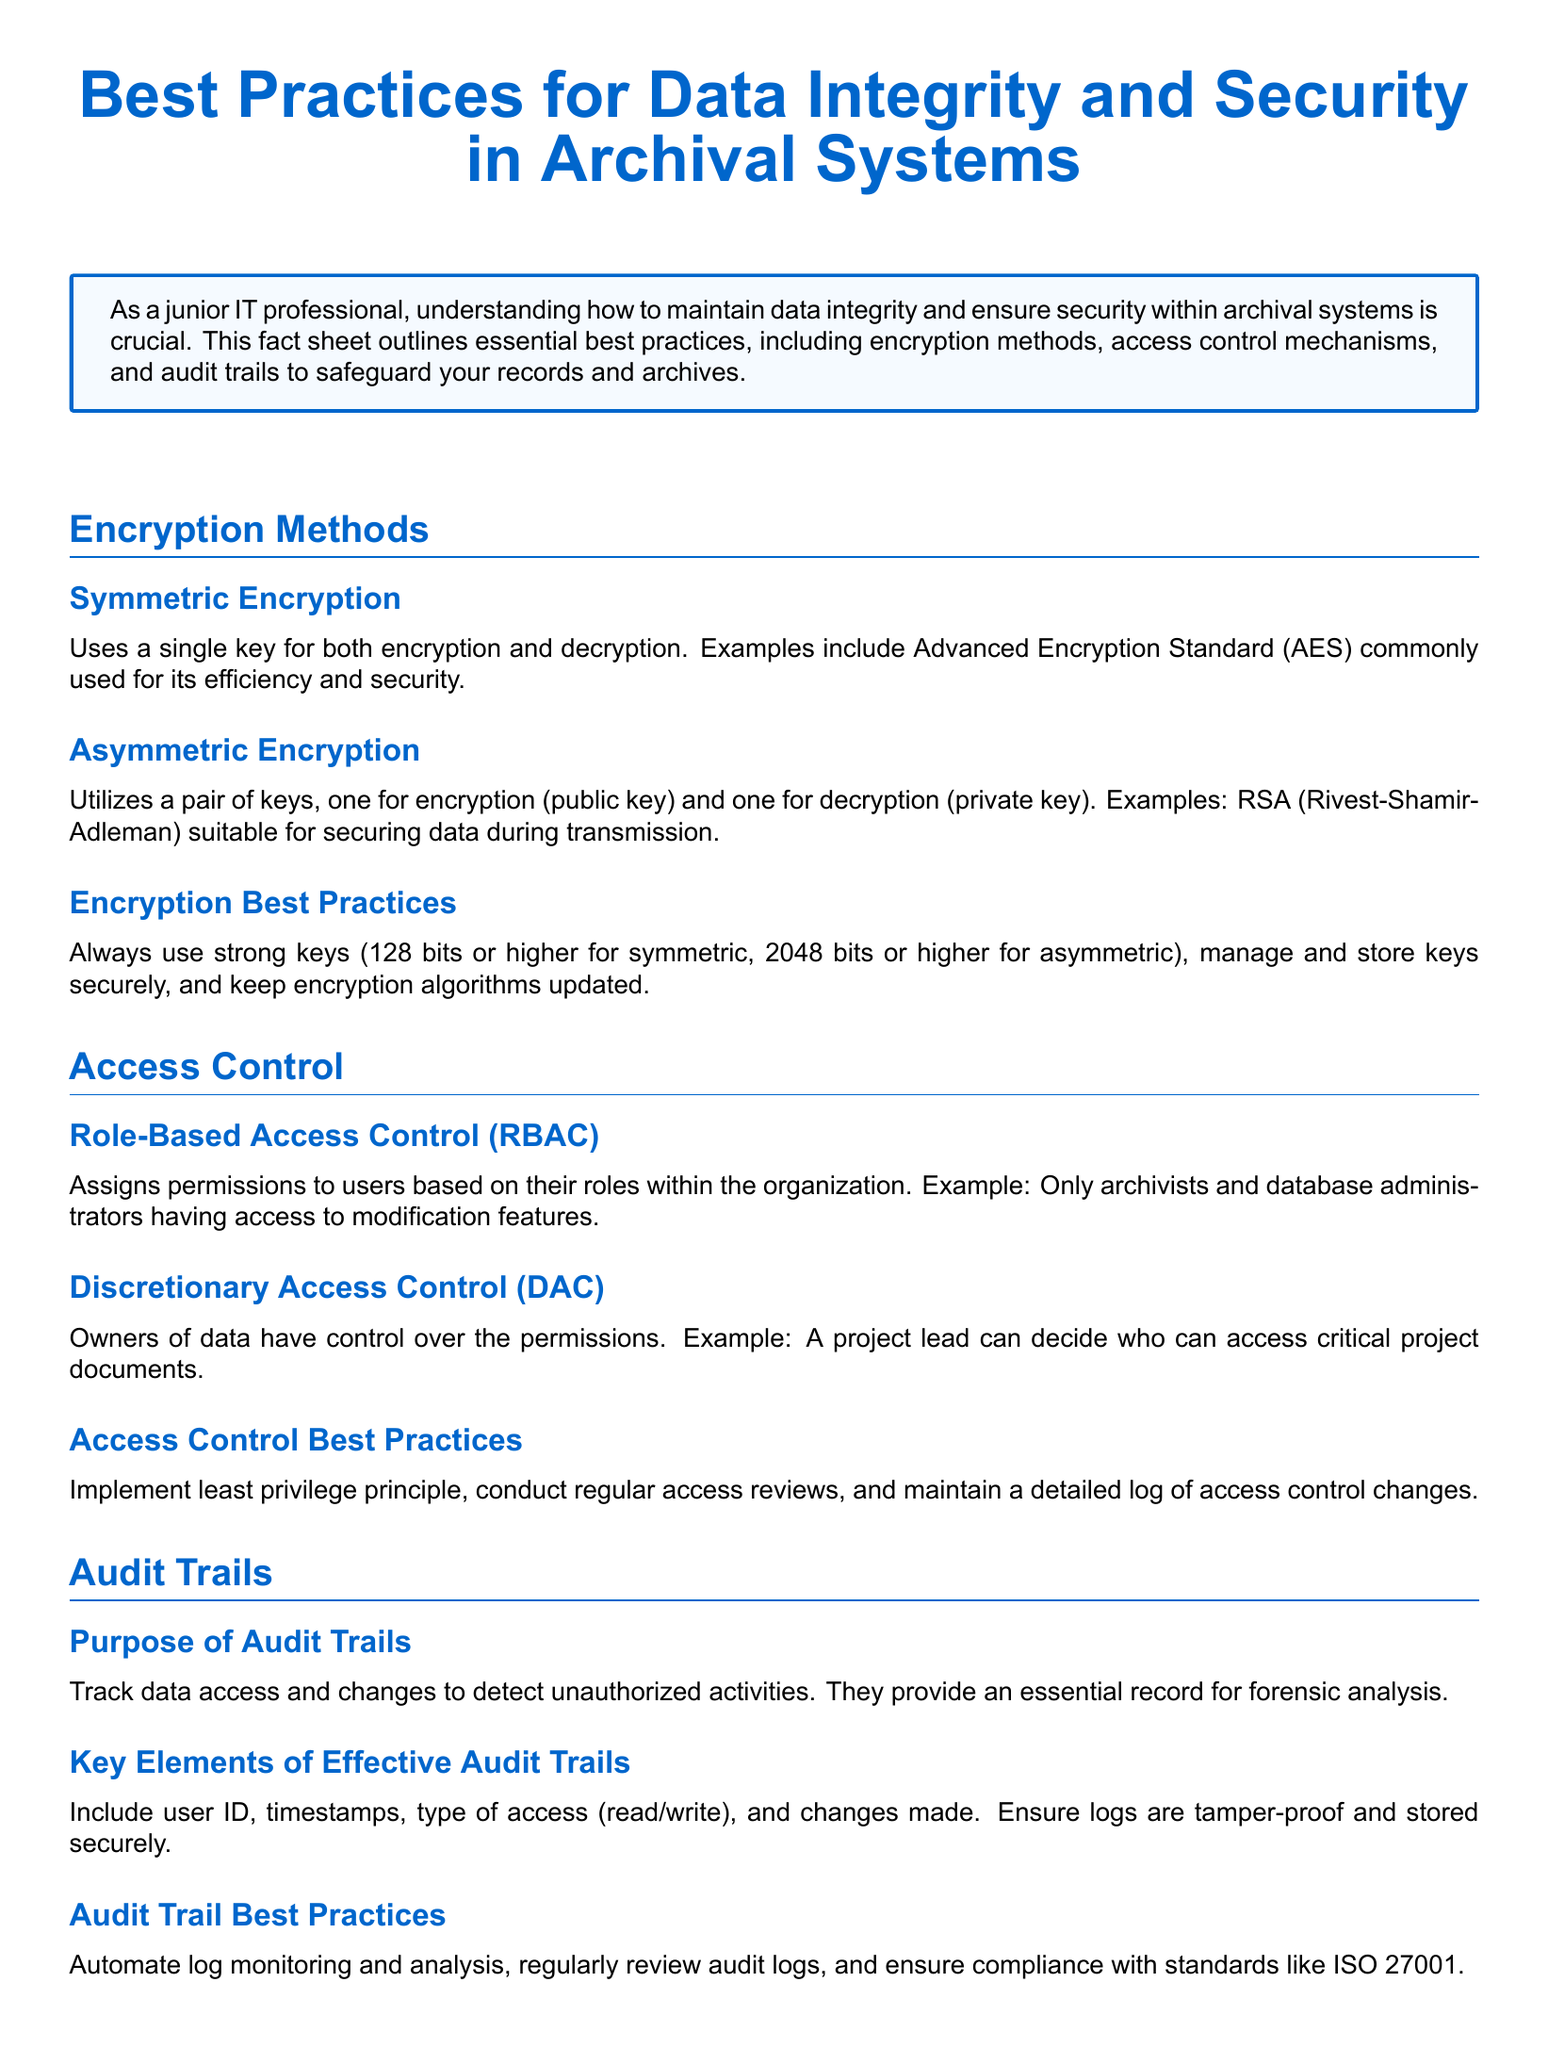What is the purpose of audit trails? The purpose of audit trails is to track data access and changes to detect unauthorized activities.
Answer: Track data access and changes What encryption method uses a single key? The document states that symmetric encryption uses a single key for both encryption and decryption.
Answer: Symmetric encryption What is the minimum key size recommended for symmetric encryption? The best practices section mentions using strong keys of 128 bits or higher for symmetric encryption.
Answer: 128 bits What access control type assigns permissions based on user roles? The section describes role-based access control (RBAC) as assigning permissions based on user roles within the organization.
Answer: Role-Based Access Control (RBAC) What are the key elements of effective audit trails? Effective audit trails include user ID, timestamps, type of access, and changes made.
Answer: User ID, timestamps, type of access, changes made What principle should be implemented for access control? The best practices section recommends implementing the least privilege principle for access control.
Answer: Least privilege principle What encryption algorithm is commonly used for its efficiency and security? The document specifies that Advanced Encryption Standard (AES) is commonly used for its efficiency and security.
Answer: Advanced Encryption Standard (AES) What compliance standard is mentioned for audit trails? The document mentions compliance with standards like ISO 27001 for audit trails.
Answer: ISO 27001 What is a recommended practice for access control reviews? The document advises conducting regular access reviews as part of access control best practices.
Answer: Regular access reviews 